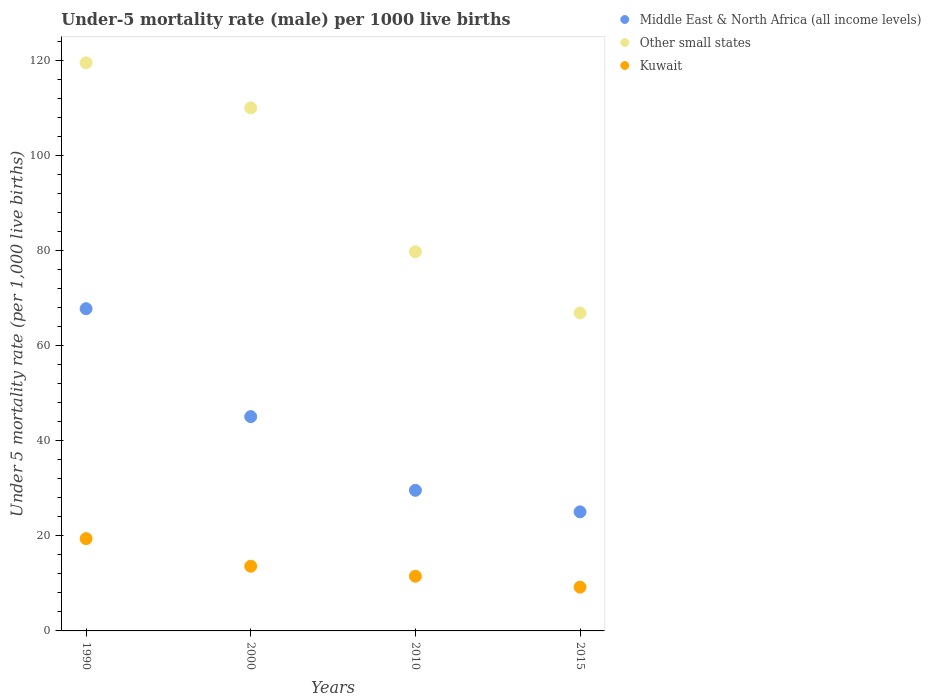Is the number of dotlines equal to the number of legend labels?
Your answer should be very brief. Yes. What is the under-five mortality rate in Middle East & North Africa (all income levels) in 2010?
Offer a terse response. 29.56. Across all years, what is the maximum under-five mortality rate in Middle East & North Africa (all income levels)?
Your response must be concise. 67.73. In which year was the under-five mortality rate in Other small states maximum?
Your answer should be compact. 1990. In which year was the under-five mortality rate in Middle East & North Africa (all income levels) minimum?
Your answer should be very brief. 2015. What is the total under-five mortality rate in Kuwait in the graph?
Your answer should be compact. 53.7. What is the difference between the under-five mortality rate in Kuwait in 2000 and that in 2010?
Keep it short and to the point. 2.1. What is the difference between the under-five mortality rate in Other small states in 1990 and the under-five mortality rate in Kuwait in 2010?
Your response must be concise. 107.92. What is the average under-five mortality rate in Kuwait per year?
Offer a terse response. 13.43. In the year 2015, what is the difference between the under-five mortality rate in Other small states and under-five mortality rate in Middle East & North Africa (all income levels)?
Your answer should be compact. 41.8. What is the ratio of the under-five mortality rate in Other small states in 1990 to that in 2015?
Your response must be concise. 1.79. Is the difference between the under-five mortality rate in Other small states in 1990 and 2015 greater than the difference between the under-five mortality rate in Middle East & North Africa (all income levels) in 1990 and 2015?
Your answer should be compact. Yes. What is the difference between the highest and the second highest under-five mortality rate in Middle East & North Africa (all income levels)?
Give a very brief answer. 22.68. What is the difference between the highest and the lowest under-five mortality rate in Kuwait?
Offer a terse response. 10.2. Is the sum of the under-five mortality rate in Other small states in 2010 and 2015 greater than the maximum under-five mortality rate in Kuwait across all years?
Keep it short and to the point. Yes. Is it the case that in every year, the sum of the under-five mortality rate in Kuwait and under-five mortality rate in Other small states  is greater than the under-five mortality rate in Middle East & North Africa (all income levels)?
Offer a terse response. Yes. How many dotlines are there?
Keep it short and to the point. 3. How many years are there in the graph?
Your answer should be compact. 4. Does the graph contain any zero values?
Ensure brevity in your answer.  No. Does the graph contain grids?
Your answer should be compact. No. How many legend labels are there?
Make the answer very short. 3. How are the legend labels stacked?
Your answer should be very brief. Vertical. What is the title of the graph?
Make the answer very short. Under-5 mortality rate (male) per 1000 live births. What is the label or title of the X-axis?
Your answer should be very brief. Years. What is the label or title of the Y-axis?
Provide a short and direct response. Under 5 mortality rate (per 1,0 live births). What is the Under 5 mortality rate (per 1,000 live births) in Middle East & North Africa (all income levels) in 1990?
Your response must be concise. 67.73. What is the Under 5 mortality rate (per 1,000 live births) of Other small states in 1990?
Your answer should be compact. 119.42. What is the Under 5 mortality rate (per 1,000 live births) in Kuwait in 1990?
Provide a short and direct response. 19.4. What is the Under 5 mortality rate (per 1,000 live births) of Middle East & North Africa (all income levels) in 2000?
Keep it short and to the point. 45.05. What is the Under 5 mortality rate (per 1,000 live births) in Other small states in 2000?
Provide a succinct answer. 109.95. What is the Under 5 mortality rate (per 1,000 live births) of Middle East & North Africa (all income levels) in 2010?
Provide a succinct answer. 29.56. What is the Under 5 mortality rate (per 1,000 live births) in Other small states in 2010?
Your answer should be compact. 79.69. What is the Under 5 mortality rate (per 1,000 live births) of Middle East & North Africa (all income levels) in 2015?
Keep it short and to the point. 25.03. What is the Under 5 mortality rate (per 1,000 live births) of Other small states in 2015?
Offer a very short reply. 66.83. What is the Under 5 mortality rate (per 1,000 live births) in Kuwait in 2015?
Keep it short and to the point. 9.2. Across all years, what is the maximum Under 5 mortality rate (per 1,000 live births) in Middle East & North Africa (all income levels)?
Provide a succinct answer. 67.73. Across all years, what is the maximum Under 5 mortality rate (per 1,000 live births) in Other small states?
Give a very brief answer. 119.42. Across all years, what is the minimum Under 5 mortality rate (per 1,000 live births) of Middle East & North Africa (all income levels)?
Offer a very short reply. 25.03. Across all years, what is the minimum Under 5 mortality rate (per 1,000 live births) in Other small states?
Your answer should be very brief. 66.83. What is the total Under 5 mortality rate (per 1,000 live births) of Middle East & North Africa (all income levels) in the graph?
Give a very brief answer. 167.36. What is the total Under 5 mortality rate (per 1,000 live births) in Other small states in the graph?
Give a very brief answer. 375.9. What is the total Under 5 mortality rate (per 1,000 live births) in Kuwait in the graph?
Your response must be concise. 53.7. What is the difference between the Under 5 mortality rate (per 1,000 live births) of Middle East & North Africa (all income levels) in 1990 and that in 2000?
Your answer should be very brief. 22.68. What is the difference between the Under 5 mortality rate (per 1,000 live births) in Other small states in 1990 and that in 2000?
Offer a very short reply. 9.47. What is the difference between the Under 5 mortality rate (per 1,000 live births) of Kuwait in 1990 and that in 2000?
Provide a succinct answer. 5.8. What is the difference between the Under 5 mortality rate (per 1,000 live births) in Middle East & North Africa (all income levels) in 1990 and that in 2010?
Provide a succinct answer. 38.17. What is the difference between the Under 5 mortality rate (per 1,000 live births) of Other small states in 1990 and that in 2010?
Offer a very short reply. 39.73. What is the difference between the Under 5 mortality rate (per 1,000 live births) in Middle East & North Africa (all income levels) in 1990 and that in 2015?
Keep it short and to the point. 42.7. What is the difference between the Under 5 mortality rate (per 1,000 live births) in Other small states in 1990 and that in 2015?
Keep it short and to the point. 52.59. What is the difference between the Under 5 mortality rate (per 1,000 live births) of Kuwait in 1990 and that in 2015?
Provide a short and direct response. 10.2. What is the difference between the Under 5 mortality rate (per 1,000 live births) in Middle East & North Africa (all income levels) in 2000 and that in 2010?
Ensure brevity in your answer.  15.49. What is the difference between the Under 5 mortality rate (per 1,000 live births) in Other small states in 2000 and that in 2010?
Offer a very short reply. 30.26. What is the difference between the Under 5 mortality rate (per 1,000 live births) in Middle East & North Africa (all income levels) in 2000 and that in 2015?
Offer a very short reply. 20.02. What is the difference between the Under 5 mortality rate (per 1,000 live births) in Other small states in 2000 and that in 2015?
Your response must be concise. 43.12. What is the difference between the Under 5 mortality rate (per 1,000 live births) in Kuwait in 2000 and that in 2015?
Make the answer very short. 4.4. What is the difference between the Under 5 mortality rate (per 1,000 live births) in Middle East & North Africa (all income levels) in 2010 and that in 2015?
Ensure brevity in your answer.  4.53. What is the difference between the Under 5 mortality rate (per 1,000 live births) of Other small states in 2010 and that in 2015?
Keep it short and to the point. 12.86. What is the difference between the Under 5 mortality rate (per 1,000 live births) in Middle East & North Africa (all income levels) in 1990 and the Under 5 mortality rate (per 1,000 live births) in Other small states in 2000?
Make the answer very short. -42.22. What is the difference between the Under 5 mortality rate (per 1,000 live births) of Middle East & North Africa (all income levels) in 1990 and the Under 5 mortality rate (per 1,000 live births) of Kuwait in 2000?
Your response must be concise. 54.13. What is the difference between the Under 5 mortality rate (per 1,000 live births) of Other small states in 1990 and the Under 5 mortality rate (per 1,000 live births) of Kuwait in 2000?
Offer a terse response. 105.82. What is the difference between the Under 5 mortality rate (per 1,000 live births) of Middle East & North Africa (all income levels) in 1990 and the Under 5 mortality rate (per 1,000 live births) of Other small states in 2010?
Your response must be concise. -11.96. What is the difference between the Under 5 mortality rate (per 1,000 live births) in Middle East & North Africa (all income levels) in 1990 and the Under 5 mortality rate (per 1,000 live births) in Kuwait in 2010?
Make the answer very short. 56.23. What is the difference between the Under 5 mortality rate (per 1,000 live births) of Other small states in 1990 and the Under 5 mortality rate (per 1,000 live births) of Kuwait in 2010?
Make the answer very short. 107.92. What is the difference between the Under 5 mortality rate (per 1,000 live births) of Middle East & North Africa (all income levels) in 1990 and the Under 5 mortality rate (per 1,000 live births) of Other small states in 2015?
Ensure brevity in your answer.  0.9. What is the difference between the Under 5 mortality rate (per 1,000 live births) of Middle East & North Africa (all income levels) in 1990 and the Under 5 mortality rate (per 1,000 live births) of Kuwait in 2015?
Your answer should be very brief. 58.53. What is the difference between the Under 5 mortality rate (per 1,000 live births) in Other small states in 1990 and the Under 5 mortality rate (per 1,000 live births) in Kuwait in 2015?
Offer a very short reply. 110.22. What is the difference between the Under 5 mortality rate (per 1,000 live births) in Middle East & North Africa (all income levels) in 2000 and the Under 5 mortality rate (per 1,000 live births) in Other small states in 2010?
Make the answer very short. -34.64. What is the difference between the Under 5 mortality rate (per 1,000 live births) of Middle East & North Africa (all income levels) in 2000 and the Under 5 mortality rate (per 1,000 live births) of Kuwait in 2010?
Keep it short and to the point. 33.55. What is the difference between the Under 5 mortality rate (per 1,000 live births) in Other small states in 2000 and the Under 5 mortality rate (per 1,000 live births) in Kuwait in 2010?
Offer a very short reply. 98.45. What is the difference between the Under 5 mortality rate (per 1,000 live births) in Middle East & North Africa (all income levels) in 2000 and the Under 5 mortality rate (per 1,000 live births) in Other small states in 2015?
Offer a very short reply. -21.78. What is the difference between the Under 5 mortality rate (per 1,000 live births) in Middle East & North Africa (all income levels) in 2000 and the Under 5 mortality rate (per 1,000 live births) in Kuwait in 2015?
Keep it short and to the point. 35.85. What is the difference between the Under 5 mortality rate (per 1,000 live births) in Other small states in 2000 and the Under 5 mortality rate (per 1,000 live births) in Kuwait in 2015?
Ensure brevity in your answer.  100.75. What is the difference between the Under 5 mortality rate (per 1,000 live births) in Middle East & North Africa (all income levels) in 2010 and the Under 5 mortality rate (per 1,000 live births) in Other small states in 2015?
Keep it short and to the point. -37.28. What is the difference between the Under 5 mortality rate (per 1,000 live births) in Middle East & North Africa (all income levels) in 2010 and the Under 5 mortality rate (per 1,000 live births) in Kuwait in 2015?
Make the answer very short. 20.36. What is the difference between the Under 5 mortality rate (per 1,000 live births) of Other small states in 2010 and the Under 5 mortality rate (per 1,000 live births) of Kuwait in 2015?
Provide a succinct answer. 70.49. What is the average Under 5 mortality rate (per 1,000 live births) of Middle East & North Africa (all income levels) per year?
Provide a succinct answer. 41.84. What is the average Under 5 mortality rate (per 1,000 live births) of Other small states per year?
Keep it short and to the point. 93.97. What is the average Under 5 mortality rate (per 1,000 live births) of Kuwait per year?
Provide a short and direct response. 13.43. In the year 1990, what is the difference between the Under 5 mortality rate (per 1,000 live births) in Middle East & North Africa (all income levels) and Under 5 mortality rate (per 1,000 live births) in Other small states?
Give a very brief answer. -51.69. In the year 1990, what is the difference between the Under 5 mortality rate (per 1,000 live births) of Middle East & North Africa (all income levels) and Under 5 mortality rate (per 1,000 live births) of Kuwait?
Your response must be concise. 48.33. In the year 1990, what is the difference between the Under 5 mortality rate (per 1,000 live births) of Other small states and Under 5 mortality rate (per 1,000 live births) of Kuwait?
Offer a terse response. 100.02. In the year 2000, what is the difference between the Under 5 mortality rate (per 1,000 live births) in Middle East & North Africa (all income levels) and Under 5 mortality rate (per 1,000 live births) in Other small states?
Provide a succinct answer. -64.9. In the year 2000, what is the difference between the Under 5 mortality rate (per 1,000 live births) of Middle East & North Africa (all income levels) and Under 5 mortality rate (per 1,000 live births) of Kuwait?
Provide a succinct answer. 31.45. In the year 2000, what is the difference between the Under 5 mortality rate (per 1,000 live births) in Other small states and Under 5 mortality rate (per 1,000 live births) in Kuwait?
Offer a very short reply. 96.35. In the year 2010, what is the difference between the Under 5 mortality rate (per 1,000 live births) of Middle East & North Africa (all income levels) and Under 5 mortality rate (per 1,000 live births) of Other small states?
Provide a succinct answer. -50.14. In the year 2010, what is the difference between the Under 5 mortality rate (per 1,000 live births) in Middle East & North Africa (all income levels) and Under 5 mortality rate (per 1,000 live births) in Kuwait?
Provide a succinct answer. 18.06. In the year 2010, what is the difference between the Under 5 mortality rate (per 1,000 live births) in Other small states and Under 5 mortality rate (per 1,000 live births) in Kuwait?
Provide a short and direct response. 68.19. In the year 2015, what is the difference between the Under 5 mortality rate (per 1,000 live births) of Middle East & North Africa (all income levels) and Under 5 mortality rate (per 1,000 live births) of Other small states?
Ensure brevity in your answer.  -41.8. In the year 2015, what is the difference between the Under 5 mortality rate (per 1,000 live births) of Middle East & North Africa (all income levels) and Under 5 mortality rate (per 1,000 live births) of Kuwait?
Offer a terse response. 15.83. In the year 2015, what is the difference between the Under 5 mortality rate (per 1,000 live births) in Other small states and Under 5 mortality rate (per 1,000 live births) in Kuwait?
Your response must be concise. 57.63. What is the ratio of the Under 5 mortality rate (per 1,000 live births) of Middle East & North Africa (all income levels) in 1990 to that in 2000?
Provide a succinct answer. 1.5. What is the ratio of the Under 5 mortality rate (per 1,000 live births) in Other small states in 1990 to that in 2000?
Your answer should be compact. 1.09. What is the ratio of the Under 5 mortality rate (per 1,000 live births) in Kuwait in 1990 to that in 2000?
Ensure brevity in your answer.  1.43. What is the ratio of the Under 5 mortality rate (per 1,000 live births) in Middle East & North Africa (all income levels) in 1990 to that in 2010?
Offer a very short reply. 2.29. What is the ratio of the Under 5 mortality rate (per 1,000 live births) in Other small states in 1990 to that in 2010?
Provide a short and direct response. 1.5. What is the ratio of the Under 5 mortality rate (per 1,000 live births) in Kuwait in 1990 to that in 2010?
Your answer should be very brief. 1.69. What is the ratio of the Under 5 mortality rate (per 1,000 live births) in Middle East & North Africa (all income levels) in 1990 to that in 2015?
Offer a terse response. 2.71. What is the ratio of the Under 5 mortality rate (per 1,000 live births) of Other small states in 1990 to that in 2015?
Make the answer very short. 1.79. What is the ratio of the Under 5 mortality rate (per 1,000 live births) of Kuwait in 1990 to that in 2015?
Offer a terse response. 2.11. What is the ratio of the Under 5 mortality rate (per 1,000 live births) of Middle East & North Africa (all income levels) in 2000 to that in 2010?
Make the answer very short. 1.52. What is the ratio of the Under 5 mortality rate (per 1,000 live births) of Other small states in 2000 to that in 2010?
Offer a terse response. 1.38. What is the ratio of the Under 5 mortality rate (per 1,000 live births) in Kuwait in 2000 to that in 2010?
Keep it short and to the point. 1.18. What is the ratio of the Under 5 mortality rate (per 1,000 live births) in Middle East & North Africa (all income levels) in 2000 to that in 2015?
Keep it short and to the point. 1.8. What is the ratio of the Under 5 mortality rate (per 1,000 live births) of Other small states in 2000 to that in 2015?
Offer a terse response. 1.65. What is the ratio of the Under 5 mortality rate (per 1,000 live births) in Kuwait in 2000 to that in 2015?
Give a very brief answer. 1.48. What is the ratio of the Under 5 mortality rate (per 1,000 live births) of Middle East & North Africa (all income levels) in 2010 to that in 2015?
Provide a succinct answer. 1.18. What is the ratio of the Under 5 mortality rate (per 1,000 live births) in Other small states in 2010 to that in 2015?
Offer a very short reply. 1.19. What is the difference between the highest and the second highest Under 5 mortality rate (per 1,000 live births) in Middle East & North Africa (all income levels)?
Your response must be concise. 22.68. What is the difference between the highest and the second highest Under 5 mortality rate (per 1,000 live births) in Other small states?
Make the answer very short. 9.47. What is the difference between the highest and the second highest Under 5 mortality rate (per 1,000 live births) of Kuwait?
Offer a terse response. 5.8. What is the difference between the highest and the lowest Under 5 mortality rate (per 1,000 live births) in Middle East & North Africa (all income levels)?
Offer a very short reply. 42.7. What is the difference between the highest and the lowest Under 5 mortality rate (per 1,000 live births) in Other small states?
Provide a succinct answer. 52.59. 